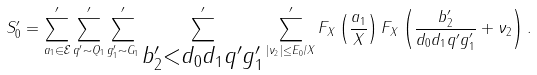Convert formula to latex. <formula><loc_0><loc_0><loc_500><loc_500>S _ { 0 } ^ { \prime } = \sum ^ { \prime } _ { a _ { 1 } \in \mathcal { E } } \sum ^ { \prime } _ { q ^ { \prime } \sim Q _ { 1 } } \sum _ { g _ { 1 } ^ { \prime } \sim G _ { 1 } } ^ { \prime } \sum ^ { \prime } _ { \substack { b _ { 2 } ^ { \prime } < d _ { 0 } d _ { 1 } q ^ { \prime } g _ { 1 } ^ { \prime } } } \sum ^ { \prime } _ { | \nu _ { 2 } | \leq E _ { 0 } / X } F _ { X } \left ( \frac { a _ { 1 } } { X } \right ) F _ { X } \left ( \frac { b _ { 2 } ^ { \prime } } { d _ { 0 } d _ { 1 } q ^ { \prime } g _ { 1 } ^ { \prime } } + \nu _ { 2 } \right ) .</formula> 